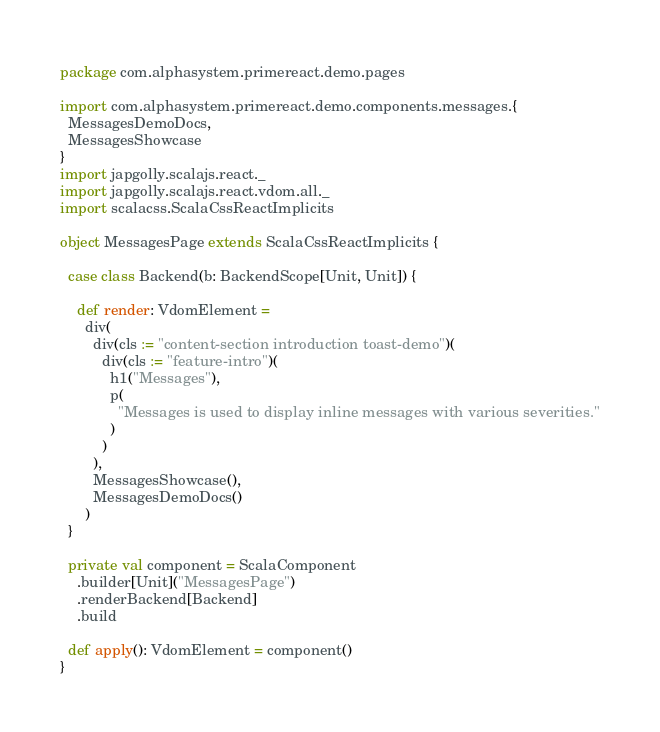<code> <loc_0><loc_0><loc_500><loc_500><_Scala_>package com.alphasystem.primereact.demo.pages

import com.alphasystem.primereact.demo.components.messages.{
  MessagesDemoDocs,
  MessagesShowcase
}
import japgolly.scalajs.react._
import japgolly.scalajs.react.vdom.all._
import scalacss.ScalaCssReactImplicits

object MessagesPage extends ScalaCssReactImplicits {

  case class Backend(b: BackendScope[Unit, Unit]) {

    def render: VdomElement =
      div(
        div(cls := "content-section introduction toast-demo")(
          div(cls := "feature-intro")(
            h1("Messages"),
            p(
              "Messages is used to display inline messages with various severities."
            )
          )
        ),
        MessagesShowcase(),
        MessagesDemoDocs()
      )
  }

  private val component = ScalaComponent
    .builder[Unit]("MessagesPage")
    .renderBackend[Backend]
    .build

  def apply(): VdomElement = component()
}
</code> 